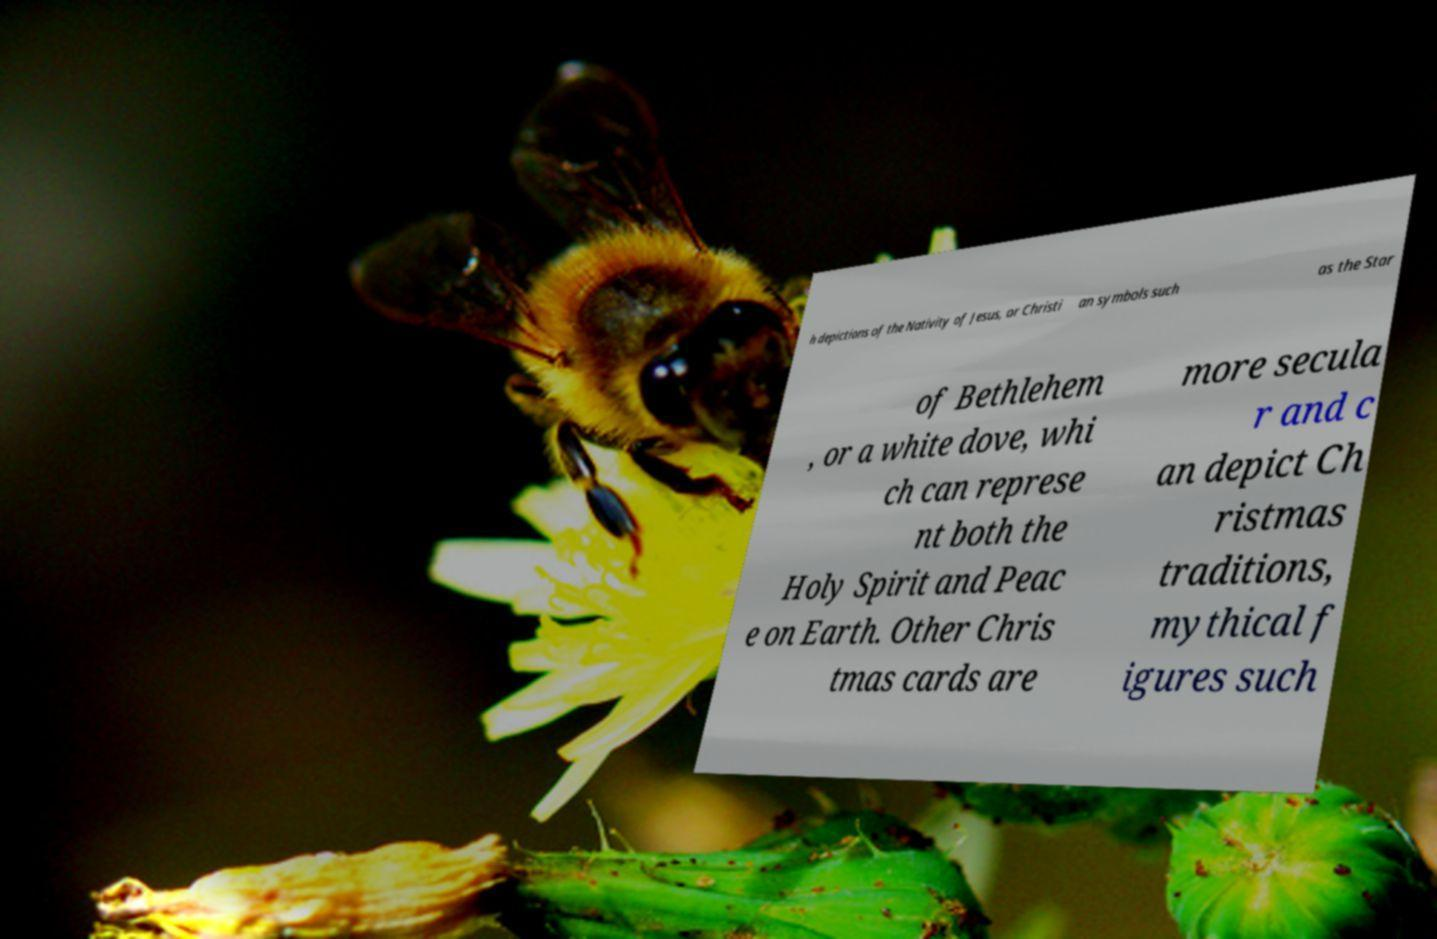Could you assist in decoding the text presented in this image and type it out clearly? h depictions of the Nativity of Jesus, or Christi an symbols such as the Star of Bethlehem , or a white dove, whi ch can represe nt both the Holy Spirit and Peac e on Earth. Other Chris tmas cards are more secula r and c an depict Ch ristmas traditions, mythical f igures such 